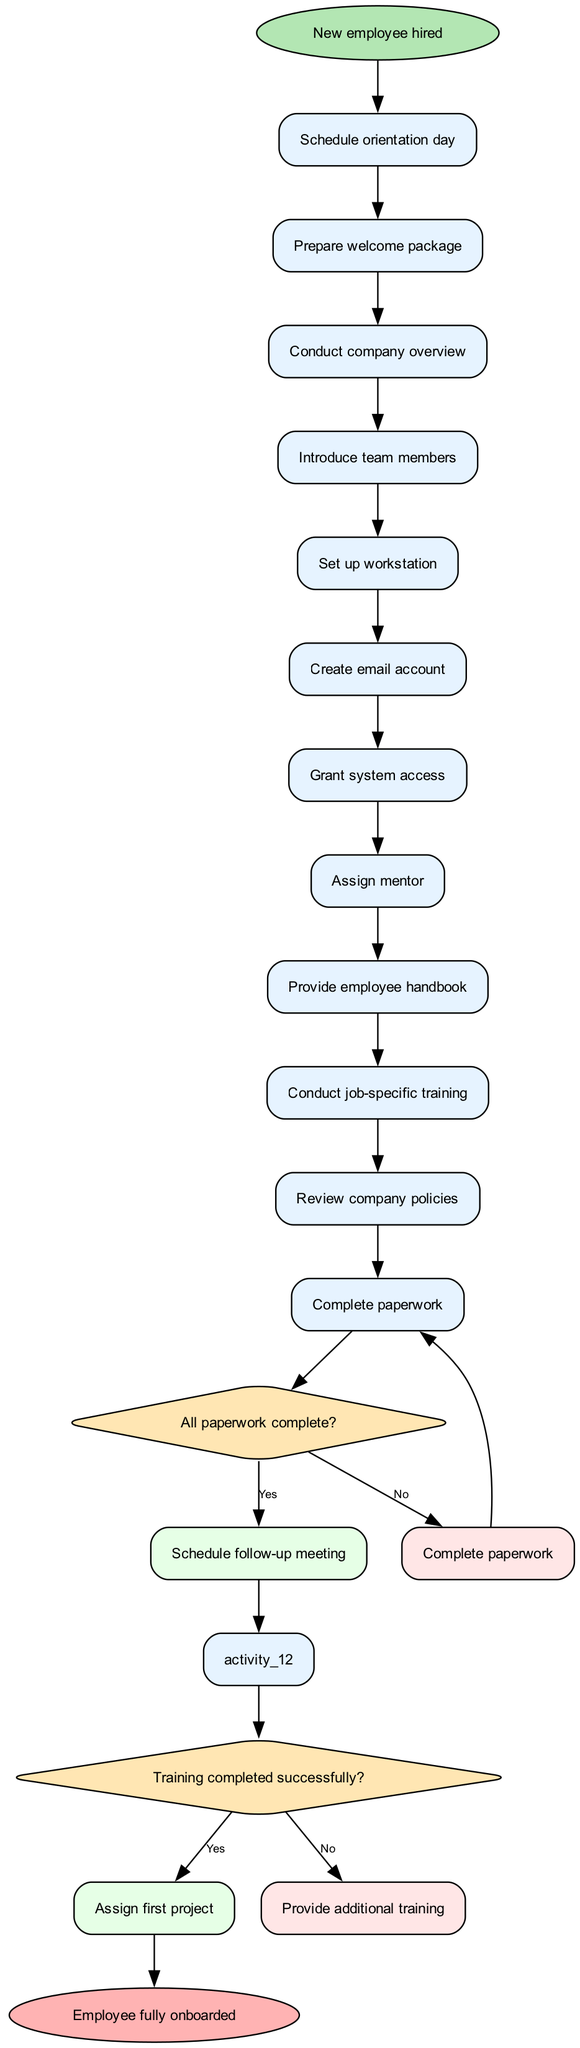What is the starting node of the diagram? The starting node is labeled as "New employee hired" and is the first node in the diagram. It signifies the beginning of the onboarding process.
Answer: New employee hired How many activities are there in total? There are 12 activities listed in the diagram, covering various steps of the onboarding process from scheduling orientation to conducting job-specific training.
Answer: 12 Which activity follows "Conduct company overview"? The activity directly following "Conduct company overview" is "Introduce team members," indicating that, after the overview, new employees will meet their colleagues.
Answer: Introduce team members What happens if all paperwork is complete? If all paperwork is complete, the process will lead to scheduling a follow-up meeting, meaning a step is taken to ensure the onboarding is progressing smoothly.
Answer: Schedule follow-up meeting What are the two outcomes of the "Training completed successfully?" decision? The two outcomes of this decision are "Assign first project" if the training is successful, and "Provide additional training" if it is not, indicating a clear path based on the training completion status.
Answer: Assign first project, Provide additional training How many decisions are present in the diagram? There are 2 decisions in the diagram, which assess the completion of paperwork and whether training was successful, guiding the flow depending on the answers.
Answer: 2 After the decision "All paperwork complete?" what is the next node if the answer is "No"? If the answer is "No" to the paperwork decision, the next node will be "Complete paperwork," indicating that the process will loop back to finish the paperwork.
Answer: Complete paperwork What is the final outcome of the workflow? The final outcome of the workflow is labeled as "Employee fully onboarded," which signifies the successful completion of the onboarding process.
Answer: Employee fully onboarded If the employee's training is not completed successfully, which activity will follow? If the training is not completed successfully, the next activity will be "Provide additional training," ensuring that the employee receives the necessary support before moving forward.
Answer: Provide additional training 